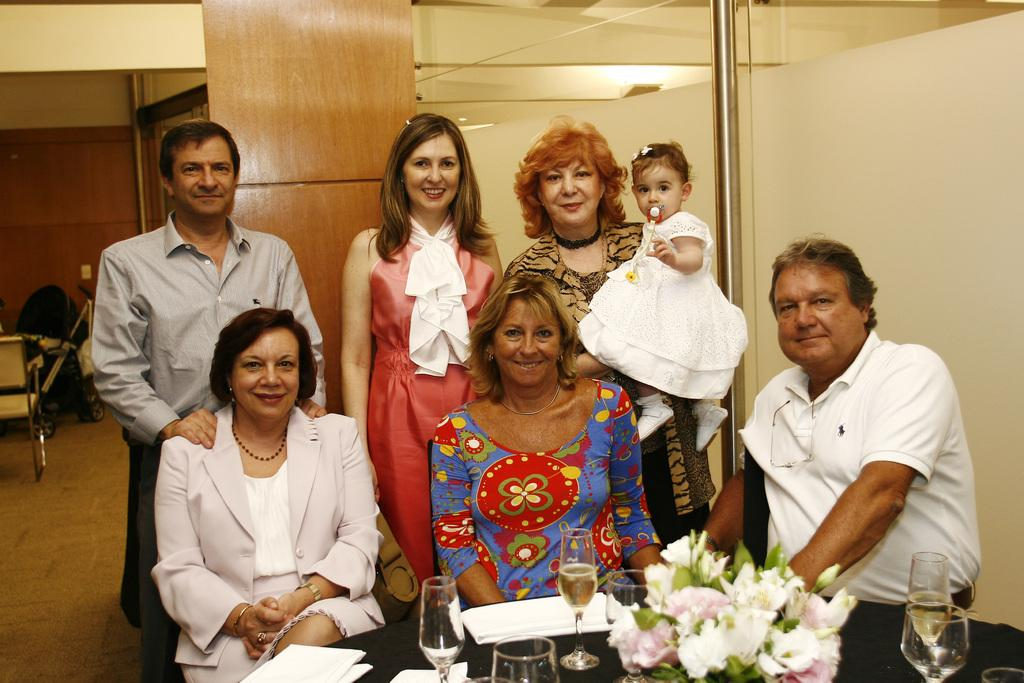How many people are in the image? There are people in the image, but the exact number is not specified. What are the people doing in the image? Some people are sitting, while others are standing. Can you describe the facial expressions of some people in the image? There are smiles on some faces in the image. What is on the table in the image? There is a table in the image with a flower and glasses on it. How many times does the beginner sneeze in the image? There is no mention of a beginner or sneezing in the image, so this question cannot be answered. Where is the shelf located in the image? There is no shelf present in the image. 